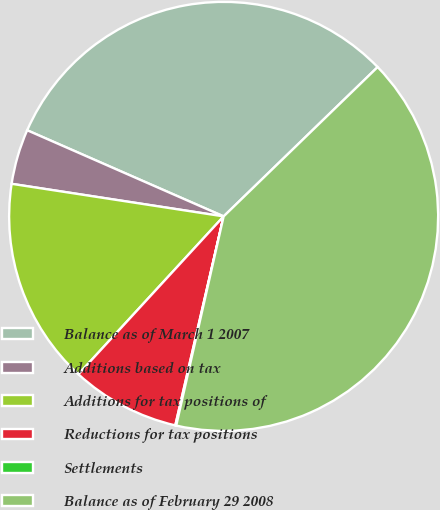Convert chart. <chart><loc_0><loc_0><loc_500><loc_500><pie_chart><fcel>Balance as of March 1 2007<fcel>Additions based on tax<fcel>Additions for tax positions of<fcel>Reductions for tax positions<fcel>Settlements<fcel>Balance as of February 29 2008<nl><fcel>31.17%<fcel>4.15%<fcel>15.59%<fcel>8.22%<fcel>0.07%<fcel>40.8%<nl></chart> 